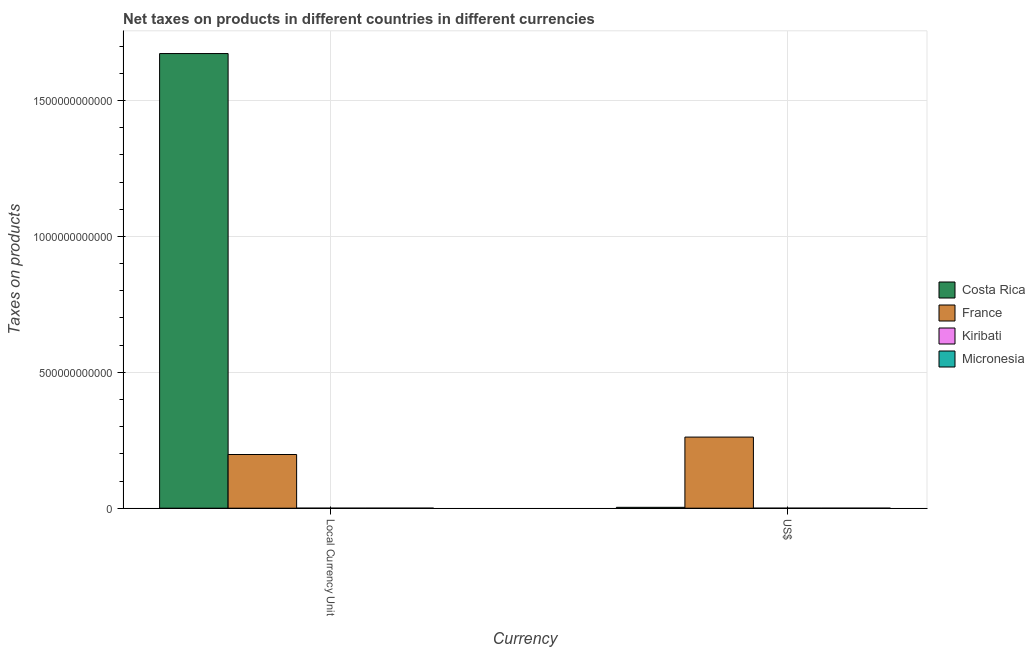How many different coloured bars are there?
Offer a very short reply. 4. How many groups of bars are there?
Your response must be concise. 2. Are the number of bars on each tick of the X-axis equal?
Give a very brief answer. Yes. How many bars are there on the 2nd tick from the left?
Offer a very short reply. 4. How many bars are there on the 2nd tick from the right?
Offer a very short reply. 4. What is the label of the 2nd group of bars from the left?
Give a very brief answer. US$. What is the net taxes in constant 2005 us$ in France?
Keep it short and to the point. 1.97e+11. Across all countries, what is the maximum net taxes in us$?
Your response must be concise. 2.62e+11. Across all countries, what is the minimum net taxes in us$?
Your response must be concise. 7.80e+06. In which country was the net taxes in constant 2005 us$ minimum?
Your answer should be compact. Kiribati. What is the total net taxes in us$ in the graph?
Provide a succinct answer. 2.65e+11. What is the difference between the net taxes in constant 2005 us$ in Micronesia and that in Kiribati?
Offer a very short reply. 1.69e+07. What is the difference between the net taxes in constant 2005 us$ in Costa Rica and the net taxes in us$ in Micronesia?
Make the answer very short. 1.67e+12. What is the average net taxes in constant 2005 us$ per country?
Make the answer very short. 4.68e+11. What is the difference between the net taxes in constant 2005 us$ and net taxes in us$ in Kiribati?
Your answer should be compact. 7.03e+05. In how many countries, is the net taxes in constant 2005 us$ greater than 300000000000 units?
Offer a very short reply. 1. What is the ratio of the net taxes in constant 2005 us$ in Costa Rica to that in Kiribati?
Give a very brief answer. 1.97e+05. Is the net taxes in constant 2005 us$ in Micronesia less than that in France?
Make the answer very short. Yes. In how many countries, is the net taxes in constant 2005 us$ greater than the average net taxes in constant 2005 us$ taken over all countries?
Give a very brief answer. 1. What does the 1st bar from the left in US$ represents?
Provide a succinct answer. Costa Rica. What does the 4th bar from the right in Local Currency Unit represents?
Offer a very short reply. Costa Rica. How many bars are there?
Provide a succinct answer. 8. Are all the bars in the graph horizontal?
Your answer should be compact. No. How many countries are there in the graph?
Provide a succinct answer. 4. What is the difference between two consecutive major ticks on the Y-axis?
Give a very brief answer. 5.00e+11. Does the graph contain any zero values?
Keep it short and to the point. No. Does the graph contain grids?
Your answer should be compact. Yes. Where does the legend appear in the graph?
Offer a terse response. Center right. How many legend labels are there?
Your answer should be compact. 4. How are the legend labels stacked?
Offer a terse response. Vertical. What is the title of the graph?
Offer a terse response. Net taxes on products in different countries in different currencies. What is the label or title of the X-axis?
Offer a terse response. Currency. What is the label or title of the Y-axis?
Make the answer very short. Taxes on products. What is the Taxes on products in Costa Rica in Local Currency Unit?
Your answer should be compact. 1.67e+12. What is the Taxes on products in France in Local Currency Unit?
Your answer should be compact. 1.97e+11. What is the Taxes on products of Kiribati in Local Currency Unit?
Keep it short and to the point. 8.50e+06. What is the Taxes on products of Micronesia in Local Currency Unit?
Make the answer very short. 2.54e+07. What is the Taxes on products of Costa Rica in US$?
Provide a short and direct response. 3.18e+09. What is the Taxes on products of France in US$?
Offer a very short reply. 2.62e+11. What is the Taxes on products in Kiribati in US$?
Offer a very short reply. 7.80e+06. What is the Taxes on products of Micronesia in US$?
Provide a short and direct response. 2.54e+07. Across all Currency, what is the maximum Taxes on products in Costa Rica?
Make the answer very short. 1.67e+12. Across all Currency, what is the maximum Taxes on products in France?
Ensure brevity in your answer.  2.62e+11. Across all Currency, what is the maximum Taxes on products of Kiribati?
Keep it short and to the point. 8.50e+06. Across all Currency, what is the maximum Taxes on products in Micronesia?
Give a very brief answer. 2.54e+07. Across all Currency, what is the minimum Taxes on products in Costa Rica?
Your answer should be compact. 3.18e+09. Across all Currency, what is the minimum Taxes on products in France?
Provide a short and direct response. 1.97e+11. Across all Currency, what is the minimum Taxes on products in Kiribati?
Provide a succinct answer. 7.80e+06. Across all Currency, what is the minimum Taxes on products in Micronesia?
Offer a terse response. 2.54e+07. What is the total Taxes on products in Costa Rica in the graph?
Provide a short and direct response. 1.68e+12. What is the total Taxes on products of France in the graph?
Offer a terse response. 4.59e+11. What is the total Taxes on products of Kiribati in the graph?
Provide a short and direct response. 1.63e+07. What is the total Taxes on products in Micronesia in the graph?
Your response must be concise. 5.09e+07. What is the difference between the Taxes on products of Costa Rica in Local Currency Unit and that in US$?
Offer a terse response. 1.67e+12. What is the difference between the Taxes on products of France in Local Currency Unit and that in US$?
Offer a terse response. -6.41e+1. What is the difference between the Taxes on products of Kiribati in Local Currency Unit and that in US$?
Keep it short and to the point. 7.03e+05. What is the difference between the Taxes on products of Micronesia in Local Currency Unit and that in US$?
Ensure brevity in your answer.  0. What is the difference between the Taxes on products of Costa Rica in Local Currency Unit and the Taxes on products of France in US$?
Give a very brief answer. 1.41e+12. What is the difference between the Taxes on products of Costa Rica in Local Currency Unit and the Taxes on products of Kiribati in US$?
Keep it short and to the point. 1.67e+12. What is the difference between the Taxes on products in Costa Rica in Local Currency Unit and the Taxes on products in Micronesia in US$?
Provide a short and direct response. 1.67e+12. What is the difference between the Taxes on products in France in Local Currency Unit and the Taxes on products in Kiribati in US$?
Make the answer very short. 1.97e+11. What is the difference between the Taxes on products in France in Local Currency Unit and the Taxes on products in Micronesia in US$?
Keep it short and to the point. 1.97e+11. What is the difference between the Taxes on products of Kiribati in Local Currency Unit and the Taxes on products of Micronesia in US$?
Offer a terse response. -1.69e+07. What is the average Taxes on products of Costa Rica per Currency?
Give a very brief answer. 8.38e+11. What is the average Taxes on products of France per Currency?
Your answer should be very brief. 2.30e+11. What is the average Taxes on products in Kiribati per Currency?
Offer a very short reply. 8.15e+06. What is the average Taxes on products in Micronesia per Currency?
Provide a short and direct response. 2.54e+07. What is the difference between the Taxes on products of Costa Rica and Taxes on products of France in Local Currency Unit?
Make the answer very short. 1.48e+12. What is the difference between the Taxes on products of Costa Rica and Taxes on products of Kiribati in Local Currency Unit?
Your answer should be very brief. 1.67e+12. What is the difference between the Taxes on products in Costa Rica and Taxes on products in Micronesia in Local Currency Unit?
Provide a succinct answer. 1.67e+12. What is the difference between the Taxes on products of France and Taxes on products of Kiribati in Local Currency Unit?
Offer a very short reply. 1.97e+11. What is the difference between the Taxes on products of France and Taxes on products of Micronesia in Local Currency Unit?
Offer a very short reply. 1.97e+11. What is the difference between the Taxes on products of Kiribati and Taxes on products of Micronesia in Local Currency Unit?
Provide a succinct answer. -1.69e+07. What is the difference between the Taxes on products of Costa Rica and Taxes on products of France in US$?
Ensure brevity in your answer.  -2.58e+11. What is the difference between the Taxes on products in Costa Rica and Taxes on products in Kiribati in US$?
Your response must be concise. 3.17e+09. What is the difference between the Taxes on products in Costa Rica and Taxes on products in Micronesia in US$?
Your response must be concise. 3.16e+09. What is the difference between the Taxes on products of France and Taxes on products of Kiribati in US$?
Provide a succinct answer. 2.62e+11. What is the difference between the Taxes on products in France and Taxes on products in Micronesia in US$?
Provide a succinct answer. 2.62e+11. What is the difference between the Taxes on products in Kiribati and Taxes on products in Micronesia in US$?
Your response must be concise. -1.76e+07. What is the ratio of the Taxes on products of Costa Rica in Local Currency Unit to that in US$?
Offer a very short reply. 525.83. What is the ratio of the Taxes on products of France in Local Currency Unit to that in US$?
Provide a short and direct response. 0.76. What is the ratio of the Taxes on products in Kiribati in Local Currency Unit to that in US$?
Provide a succinct answer. 1.09. What is the difference between the highest and the second highest Taxes on products of Costa Rica?
Your response must be concise. 1.67e+12. What is the difference between the highest and the second highest Taxes on products of France?
Ensure brevity in your answer.  6.41e+1. What is the difference between the highest and the second highest Taxes on products in Kiribati?
Offer a terse response. 7.03e+05. What is the difference between the highest and the lowest Taxes on products of Costa Rica?
Your response must be concise. 1.67e+12. What is the difference between the highest and the lowest Taxes on products in France?
Provide a succinct answer. 6.41e+1. What is the difference between the highest and the lowest Taxes on products of Kiribati?
Provide a succinct answer. 7.03e+05. What is the difference between the highest and the lowest Taxes on products in Micronesia?
Offer a very short reply. 0. 